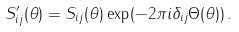<formula> <loc_0><loc_0><loc_500><loc_500>S _ { i j } ^ { \prime } ( \theta ) = S _ { i j } ( \theta ) \exp ( - 2 \pi i \delta _ { i j } \Theta ( \theta ) ) \, .</formula> 